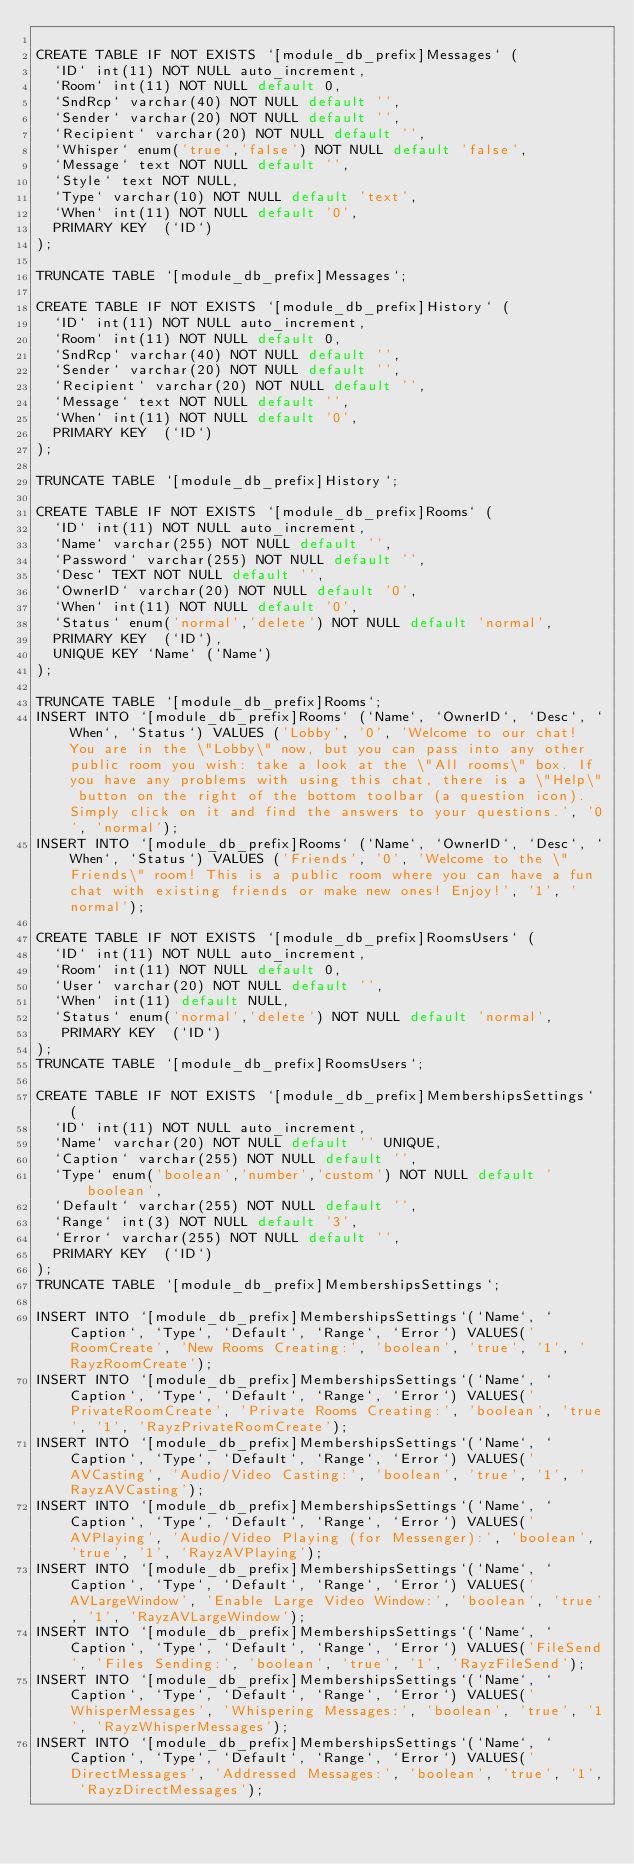Convert code to text. <code><loc_0><loc_0><loc_500><loc_500><_SQL_>
CREATE TABLE IF NOT EXISTS `[module_db_prefix]Messages` (
  `ID` int(11) NOT NULL auto_increment,
  `Room` int(11) NOT NULL default 0, 
  `SndRcp` varchar(40) NOT NULL default '',
  `Sender` varchar(20) NOT NULL default '',
  `Recipient` varchar(20) NOT NULL default '', 
  `Whisper` enum('true','false') NOT NULL default 'false', 
  `Message` text NOT NULL default '',
  `Style` text NOT NULL,
  `Type` varchar(10) NOT NULL default 'text', 
  `When` int(11) NOT NULL default '0',
  PRIMARY KEY  (`ID`)
);

TRUNCATE TABLE `[module_db_prefix]Messages`;

CREATE TABLE IF NOT EXISTS `[module_db_prefix]History` (
  `ID` int(11) NOT NULL auto_increment,
  `Room` int(11) NOT NULL default 0, 
  `SndRcp` varchar(40) NOT NULL default '', 
  `Sender` varchar(20) NOT NULL default '', 
  `Recipient` varchar(20) NOT NULL default '', 
  `Message` text NOT NULL default '',
  `When` int(11) NOT NULL default '0',
  PRIMARY KEY  (`ID`)
);

TRUNCATE TABLE `[module_db_prefix]History`;

CREATE TABLE IF NOT EXISTS `[module_db_prefix]Rooms` (
  `ID` int(11) NOT NULL auto_increment,  
  `Name` varchar(255) NOT NULL default '',
  `Password` varchar(255) NOT NULL default '',
  `Desc` TEXT NOT NULL default '',
  `OwnerID` varchar(20) NOT NULL default '0', 
  `When` int(11) NOT NULL default '0',
  `Status` enum('normal','delete') NOT NULL default 'normal',
  PRIMARY KEY  (`ID`),
  UNIQUE KEY `Name` (`Name`)
);

TRUNCATE TABLE `[module_db_prefix]Rooms`;
INSERT INTO `[module_db_prefix]Rooms` (`Name`, `OwnerID`, `Desc`, `When`, `Status`) VALUES ('Lobby', '0', 'Welcome to our chat! You are in the \"Lobby\" now, but you can pass into any other public room you wish: take a look at the \"All rooms\" box. If you have any problems with using this chat, there is a \"Help\" button on the right of the bottom toolbar (a question icon). Simply click on it and find the answers to your questions.', '0', 'normal');
INSERT INTO `[module_db_prefix]Rooms` (`Name`, `OwnerID`, `Desc`, `When`, `Status`) VALUES ('Friends', '0', 'Welcome to the \"Friends\" room! This is a public room where you can have a fun chat with existing friends or make new ones! Enjoy!', '1', 'normal');

CREATE TABLE IF NOT EXISTS `[module_db_prefix]RoomsUsers` (
  `ID` int(11) NOT NULL auto_increment,  
  `Room` int(11) NOT NULL default 0,
  `User` varchar(20) NOT NULL default '',
  `When` int(11) default NULL,
  `Status` enum('normal','delete') NOT NULL default 'normal',
   PRIMARY KEY  (`ID`)
);
TRUNCATE TABLE `[module_db_prefix]RoomsUsers`;

CREATE TABLE IF NOT EXISTS `[module_db_prefix]MembershipsSettings` (
  `ID` int(11) NOT NULL auto_increment,
  `Name` varchar(20) NOT NULL default '' UNIQUE,
  `Caption` varchar(255) NOT NULL default '',
  `Type` enum('boolean','number','custom') NOT NULL default 'boolean',
  `Default` varchar(255) NOT NULL default '',
  `Range` int(3) NOT NULL default '3',
  `Error` varchar(255) NOT NULL default '',
  PRIMARY KEY  (`ID`)
);
TRUNCATE TABLE `[module_db_prefix]MembershipsSettings`;

INSERT INTO `[module_db_prefix]MembershipsSettings`(`Name`, `Caption`, `Type`, `Default`, `Range`, `Error`) VALUES('RoomCreate', 'New Rooms Creating:', 'boolean', 'true', '1', 'RayzRoomCreate');
INSERT INTO `[module_db_prefix]MembershipsSettings`(`Name`, `Caption`, `Type`, `Default`, `Range`, `Error`) VALUES('PrivateRoomCreate', 'Private Rooms Creating:', 'boolean', 'true', '1', 'RayzPrivateRoomCreate');
INSERT INTO `[module_db_prefix]MembershipsSettings`(`Name`, `Caption`, `Type`, `Default`, `Range`, `Error`) VALUES('AVCasting', 'Audio/Video Casting:', 'boolean', 'true', '1', 'RayzAVCasting');
INSERT INTO `[module_db_prefix]MembershipsSettings`(`Name`, `Caption`, `Type`, `Default`, `Range`, `Error`) VALUES('AVPlaying', 'Audio/Video Playing (for Messenger):', 'boolean', 'true', '1', 'RayzAVPlaying');
INSERT INTO `[module_db_prefix]MembershipsSettings`(`Name`, `Caption`, `Type`, `Default`, `Range`, `Error`) VALUES('AVLargeWindow', 'Enable Large Video Window:', 'boolean', 'true', '1', 'RayzAVLargeWindow');
INSERT INTO `[module_db_prefix]MembershipsSettings`(`Name`, `Caption`, `Type`, `Default`, `Range`, `Error`) VALUES('FileSend', 'Files Sending:', 'boolean', 'true', '1', 'RayzFileSend');
INSERT INTO `[module_db_prefix]MembershipsSettings`(`Name`, `Caption`, `Type`, `Default`, `Range`, `Error`) VALUES('WhisperMessages', 'Whispering Messages:', 'boolean', 'true', '1', 'RayzWhisperMessages');
INSERT INTO `[module_db_prefix]MembershipsSettings`(`Name`, `Caption`, `Type`, `Default`, `Range`, `Error`) VALUES('DirectMessages', 'Addressed Messages:', 'boolean', 'true', '1', 'RayzDirectMessages');</code> 